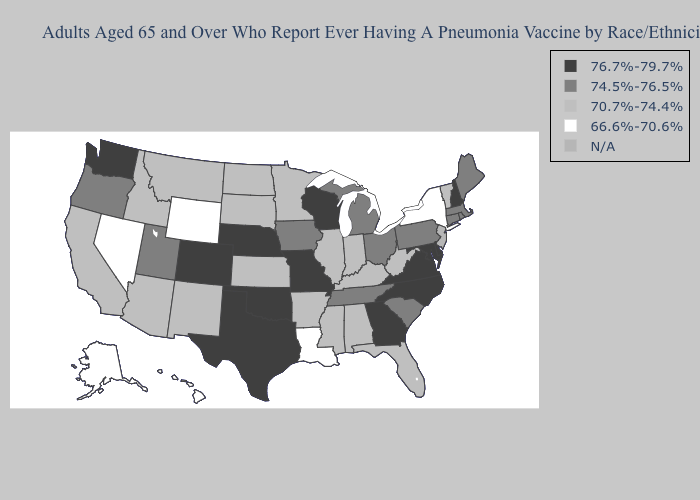Name the states that have a value in the range 74.5%-76.5%?
Write a very short answer. Connecticut, Iowa, Maine, Massachusetts, Michigan, Ohio, Oregon, Pennsylvania, Rhode Island, South Carolina, Tennessee, Utah. What is the lowest value in the USA?
Write a very short answer. 66.6%-70.6%. Does the first symbol in the legend represent the smallest category?
Keep it brief. No. Does Maryland have the highest value in the South?
Concise answer only. Yes. What is the highest value in the MidWest ?
Concise answer only. 76.7%-79.7%. What is the value of Wyoming?
Be succinct. 66.6%-70.6%. Name the states that have a value in the range N/A?
Concise answer only. New Jersey. Name the states that have a value in the range 76.7%-79.7%?
Write a very short answer. Colorado, Delaware, Georgia, Maryland, Missouri, Nebraska, New Hampshire, North Carolina, Oklahoma, Texas, Virginia, Washington, Wisconsin. Name the states that have a value in the range 76.7%-79.7%?
Quick response, please. Colorado, Delaware, Georgia, Maryland, Missouri, Nebraska, New Hampshire, North Carolina, Oklahoma, Texas, Virginia, Washington, Wisconsin. What is the value of Virginia?
Quick response, please. 76.7%-79.7%. Does the map have missing data?
Answer briefly. Yes. What is the value of Washington?
Quick response, please. 76.7%-79.7%. What is the lowest value in states that border Texas?
Give a very brief answer. 66.6%-70.6%. What is the lowest value in the Northeast?
Short answer required. 66.6%-70.6%. 